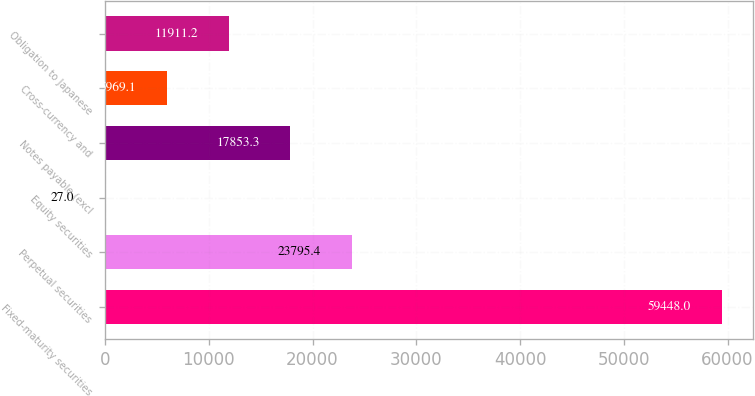<chart> <loc_0><loc_0><loc_500><loc_500><bar_chart><fcel>Fixed-maturity securities<fcel>Perpetual securities<fcel>Equity securities<fcel>Notes payable (excl<fcel>Cross-currency and<fcel>Obligation to Japanese<nl><fcel>59448<fcel>23795.4<fcel>27<fcel>17853.3<fcel>5969.1<fcel>11911.2<nl></chart> 